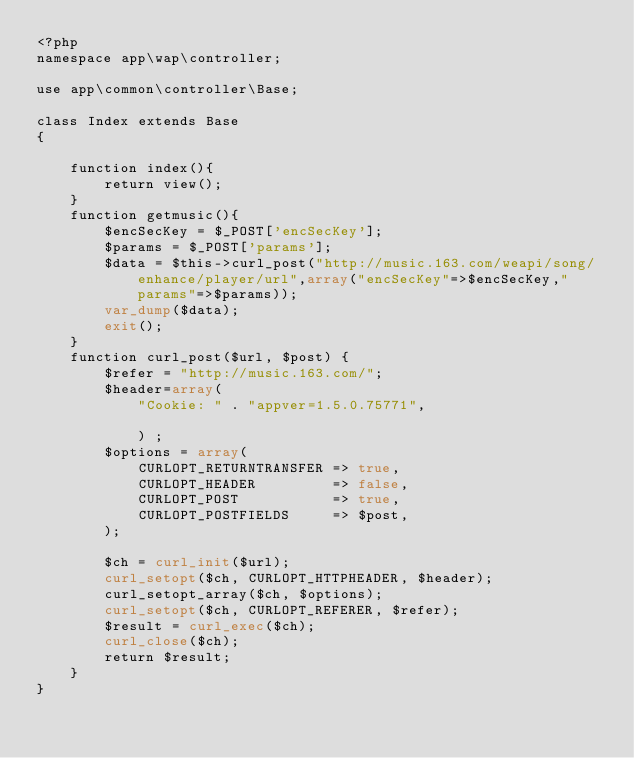Convert code to text. <code><loc_0><loc_0><loc_500><loc_500><_PHP_><?php
namespace app\wap\controller;

use app\common\controller\Base;

class Index extends Base
{

	function index(){
		return view();
	}
	function getmusic(){
		$encSecKey = $_POST['encSecKey'];
		$params = $_POST['params'];
		$data = $this->curl_post("http://music.163.com/weapi/song/enhance/player/url",array("encSecKey"=>$encSecKey,"params"=>$params));	
		var_dump($data);  
		exit();
	}
	function curl_post($url, $post) {  
		$refer = "http://music.163.com/";
	    $header=array(
	    	"Cookie: " . "appver=1.5.0.75771",
	    
	    	) ;
	    $options = array(  
	        CURLOPT_RETURNTRANSFER => true,  
	        CURLOPT_HEADER         => false,  
	        CURLOPT_POST           => true,  
	        CURLOPT_POSTFIELDS     => $post,  
	    );  
	  
	    $ch = curl_init($url);  
	    curl_setopt($ch, CURLOPT_HTTPHEADER, $header);
	    curl_setopt_array($ch, $options);  
	    curl_setopt($ch, CURLOPT_REFERER, $refer);
	    $result = curl_exec($ch);  
	    curl_close($ch); 
	    return $result;  
	}  
}</code> 